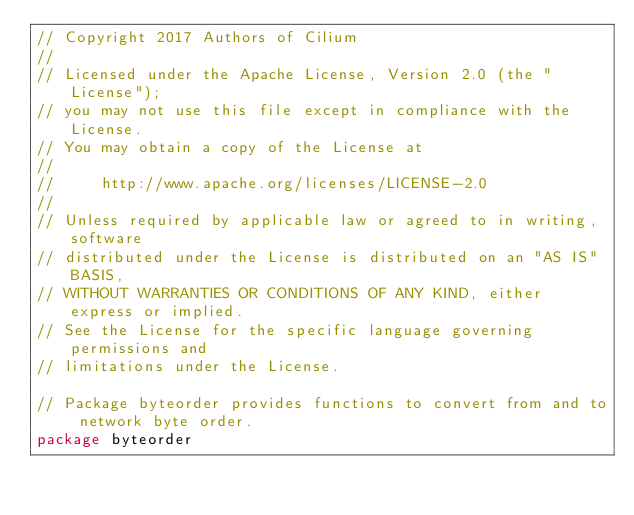<code> <loc_0><loc_0><loc_500><loc_500><_Go_>// Copyright 2017 Authors of Cilium
//
// Licensed under the Apache License, Version 2.0 (the "License");
// you may not use this file except in compliance with the License.
// You may obtain a copy of the License at
//
//     http://www.apache.org/licenses/LICENSE-2.0
//
// Unless required by applicable law or agreed to in writing, software
// distributed under the License is distributed on an "AS IS" BASIS,
// WITHOUT WARRANTIES OR CONDITIONS OF ANY KIND, either express or implied.
// See the License for the specific language governing permissions and
// limitations under the License.

// Package byteorder provides functions to convert from and to network byte order.
package byteorder
</code> 